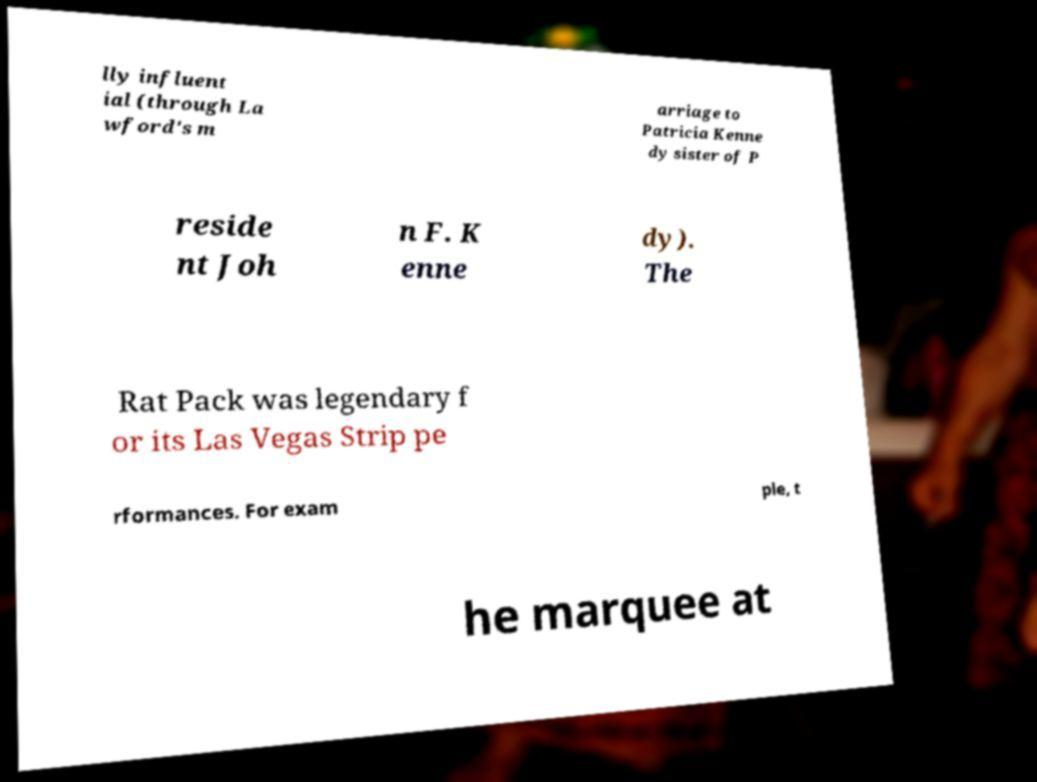Please identify and transcribe the text found in this image. lly influent ial (through La wford's m arriage to Patricia Kenne dy sister of P reside nt Joh n F. K enne dy). The Rat Pack was legendary f or its Las Vegas Strip pe rformances. For exam ple, t he marquee at 